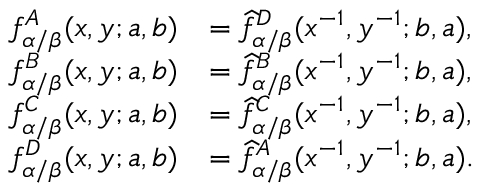Convert formula to latex. <formula><loc_0><loc_0><loc_500><loc_500>\begin{array} { r l } { f _ { \alpha / \beta } ^ { A } ( x , y ; a , b ) } & { = \widehat { f } _ { \alpha / \beta } ^ { D } ( x ^ { - 1 } , y ^ { - 1 } ; b , a ) , } \\ { f _ { \alpha / \beta } ^ { B } ( x , y ; a , b ) } & { = \widehat { f } _ { \alpha / \beta } ^ { B } ( x ^ { - 1 } , y ^ { - 1 } ; b , a ) , } \\ { f _ { \alpha / \beta } ^ { C } ( x , y ; a , b ) } & { = \widehat { f } _ { \alpha / \beta } ^ { C } ( x ^ { - 1 } , y ^ { - 1 } ; b , a ) , } \\ { f _ { \alpha / \beta } ^ { D } ( x , y ; a , b ) } & { = \widehat { f } _ { \alpha / \beta } ^ { A } ( x ^ { - 1 } , y ^ { - 1 } ; b , a ) . } \end{array}</formula> 